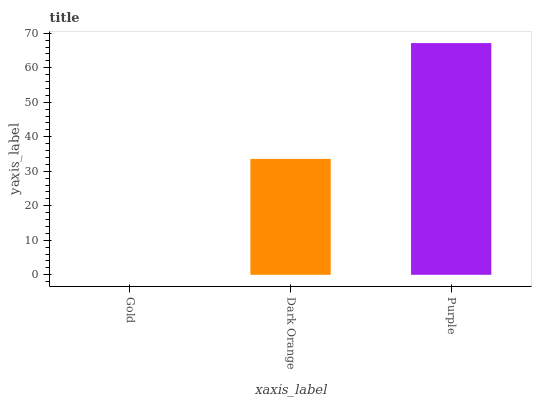Is Gold the minimum?
Answer yes or no. Yes. Is Purple the maximum?
Answer yes or no. Yes. Is Dark Orange the minimum?
Answer yes or no. No. Is Dark Orange the maximum?
Answer yes or no. No. Is Dark Orange greater than Gold?
Answer yes or no. Yes. Is Gold less than Dark Orange?
Answer yes or no. Yes. Is Gold greater than Dark Orange?
Answer yes or no. No. Is Dark Orange less than Gold?
Answer yes or no. No. Is Dark Orange the high median?
Answer yes or no. Yes. Is Dark Orange the low median?
Answer yes or no. Yes. Is Purple the high median?
Answer yes or no. No. Is Gold the low median?
Answer yes or no. No. 